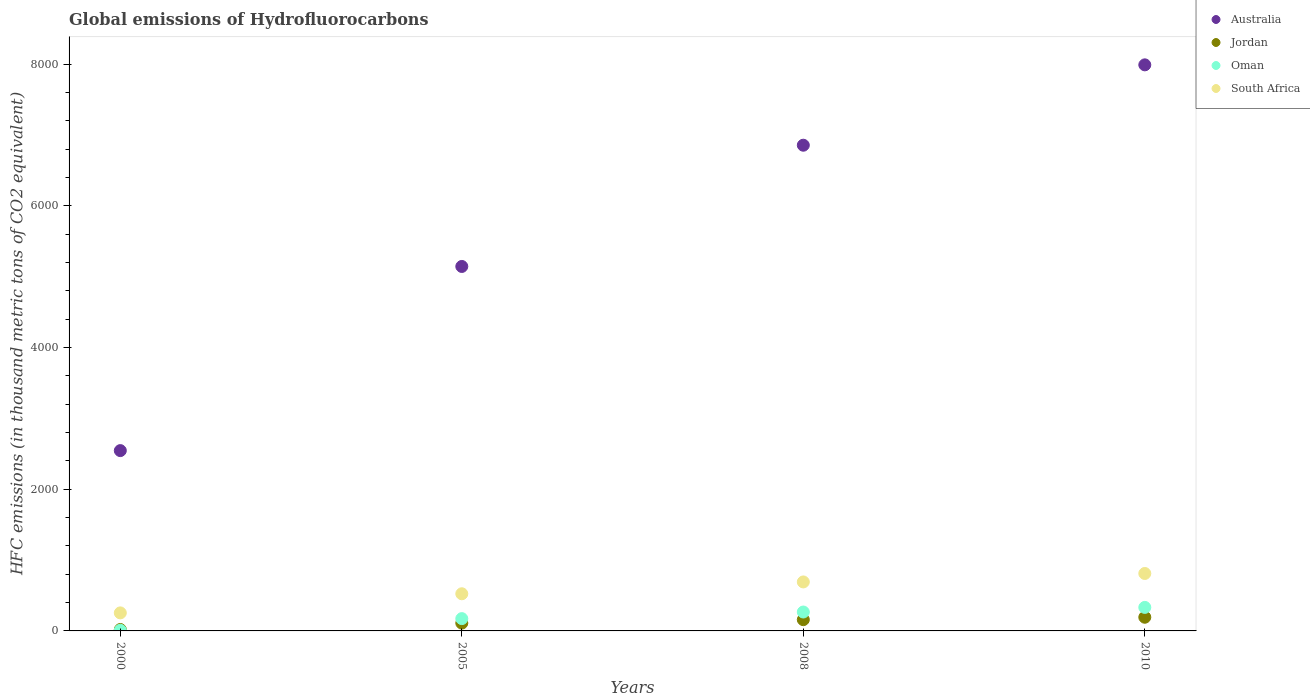How many different coloured dotlines are there?
Offer a very short reply. 4. Is the number of dotlines equal to the number of legend labels?
Provide a short and direct response. Yes. What is the global emissions of Hydrofluorocarbons in South Africa in 2000?
Make the answer very short. 254.6. Across all years, what is the maximum global emissions of Hydrofluorocarbons in Jordan?
Make the answer very short. 193. Across all years, what is the minimum global emissions of Hydrofluorocarbons in Australia?
Your response must be concise. 2545.7. In which year was the global emissions of Hydrofluorocarbons in Jordan maximum?
Keep it short and to the point. 2010. What is the total global emissions of Hydrofluorocarbons in Oman in the graph?
Provide a short and direct response. 781.1. What is the difference between the global emissions of Hydrofluorocarbons in Jordan in 2005 and that in 2010?
Give a very brief answer. -82.7. What is the difference between the global emissions of Hydrofluorocarbons in Jordan in 2005 and the global emissions of Hydrofluorocarbons in South Africa in 2010?
Your answer should be compact. -700.7. What is the average global emissions of Hydrofluorocarbons in Australia per year?
Keep it short and to the point. 5635.18. In the year 2008, what is the difference between the global emissions of Hydrofluorocarbons in Jordan and global emissions of Hydrofluorocarbons in South Africa?
Make the answer very short. -532.8. In how many years, is the global emissions of Hydrofluorocarbons in Oman greater than 3600 thousand metric tons?
Your answer should be very brief. 0. What is the ratio of the global emissions of Hydrofluorocarbons in Jordan in 2000 to that in 2008?
Make the answer very short. 0.12. Is the global emissions of Hydrofluorocarbons in Australia in 2000 less than that in 2005?
Your response must be concise. Yes. Is the difference between the global emissions of Hydrofluorocarbons in Jordan in 2000 and 2008 greater than the difference between the global emissions of Hydrofluorocarbons in South Africa in 2000 and 2008?
Ensure brevity in your answer.  Yes. What is the difference between the highest and the second highest global emissions of Hydrofluorocarbons in Jordan?
Provide a short and direct response. 34.2. What is the difference between the highest and the lowest global emissions of Hydrofluorocarbons in Australia?
Your answer should be very brief. 5446.3. In how many years, is the global emissions of Hydrofluorocarbons in Oman greater than the average global emissions of Hydrofluorocarbons in Oman taken over all years?
Ensure brevity in your answer.  2. Is the sum of the global emissions of Hydrofluorocarbons in Oman in 2005 and 2008 greater than the maximum global emissions of Hydrofluorocarbons in South Africa across all years?
Provide a short and direct response. No. Is it the case that in every year, the sum of the global emissions of Hydrofluorocarbons in Jordan and global emissions of Hydrofluorocarbons in South Africa  is greater than the sum of global emissions of Hydrofluorocarbons in Australia and global emissions of Hydrofluorocarbons in Oman?
Offer a very short reply. No. Is it the case that in every year, the sum of the global emissions of Hydrofluorocarbons in Jordan and global emissions of Hydrofluorocarbons in Oman  is greater than the global emissions of Hydrofluorocarbons in Australia?
Your answer should be very brief. No. Does the global emissions of Hydrofluorocarbons in Australia monotonically increase over the years?
Your answer should be very brief. Yes. Is the global emissions of Hydrofluorocarbons in Australia strictly greater than the global emissions of Hydrofluorocarbons in Jordan over the years?
Provide a short and direct response. Yes. Is the global emissions of Hydrofluorocarbons in Jordan strictly less than the global emissions of Hydrofluorocarbons in Australia over the years?
Your response must be concise. Yes. How many years are there in the graph?
Your answer should be compact. 4. Are the values on the major ticks of Y-axis written in scientific E-notation?
Make the answer very short. No. Does the graph contain any zero values?
Offer a very short reply. No. Where does the legend appear in the graph?
Provide a short and direct response. Top right. How are the legend labels stacked?
Ensure brevity in your answer.  Vertical. What is the title of the graph?
Make the answer very short. Global emissions of Hydrofluorocarbons. What is the label or title of the X-axis?
Provide a short and direct response. Years. What is the label or title of the Y-axis?
Give a very brief answer. HFC emissions (in thousand metric tons of CO2 equivalent). What is the HFC emissions (in thousand metric tons of CO2 equivalent) of Australia in 2000?
Offer a very short reply. 2545.7. What is the HFC emissions (in thousand metric tons of CO2 equivalent) in Jordan in 2000?
Provide a short and direct response. 19.7. What is the HFC emissions (in thousand metric tons of CO2 equivalent) of South Africa in 2000?
Offer a terse response. 254.6. What is the HFC emissions (in thousand metric tons of CO2 equivalent) of Australia in 2005?
Provide a short and direct response. 5145.6. What is the HFC emissions (in thousand metric tons of CO2 equivalent) in Jordan in 2005?
Keep it short and to the point. 110.3. What is the HFC emissions (in thousand metric tons of CO2 equivalent) of Oman in 2005?
Give a very brief answer. 173.6. What is the HFC emissions (in thousand metric tons of CO2 equivalent) in South Africa in 2005?
Ensure brevity in your answer.  524.5. What is the HFC emissions (in thousand metric tons of CO2 equivalent) of Australia in 2008?
Provide a short and direct response. 6857.4. What is the HFC emissions (in thousand metric tons of CO2 equivalent) of Jordan in 2008?
Provide a succinct answer. 158.8. What is the HFC emissions (in thousand metric tons of CO2 equivalent) in Oman in 2008?
Make the answer very short. 266.9. What is the HFC emissions (in thousand metric tons of CO2 equivalent) of South Africa in 2008?
Your response must be concise. 691.6. What is the HFC emissions (in thousand metric tons of CO2 equivalent) of Australia in 2010?
Your answer should be very brief. 7992. What is the HFC emissions (in thousand metric tons of CO2 equivalent) in Jordan in 2010?
Your answer should be compact. 193. What is the HFC emissions (in thousand metric tons of CO2 equivalent) of Oman in 2010?
Your answer should be very brief. 332. What is the HFC emissions (in thousand metric tons of CO2 equivalent) in South Africa in 2010?
Your response must be concise. 811. Across all years, what is the maximum HFC emissions (in thousand metric tons of CO2 equivalent) of Australia?
Your answer should be compact. 7992. Across all years, what is the maximum HFC emissions (in thousand metric tons of CO2 equivalent) in Jordan?
Keep it short and to the point. 193. Across all years, what is the maximum HFC emissions (in thousand metric tons of CO2 equivalent) in Oman?
Your answer should be very brief. 332. Across all years, what is the maximum HFC emissions (in thousand metric tons of CO2 equivalent) in South Africa?
Provide a succinct answer. 811. Across all years, what is the minimum HFC emissions (in thousand metric tons of CO2 equivalent) in Australia?
Give a very brief answer. 2545.7. Across all years, what is the minimum HFC emissions (in thousand metric tons of CO2 equivalent) of Oman?
Make the answer very short. 8.6. Across all years, what is the minimum HFC emissions (in thousand metric tons of CO2 equivalent) of South Africa?
Your answer should be compact. 254.6. What is the total HFC emissions (in thousand metric tons of CO2 equivalent) in Australia in the graph?
Keep it short and to the point. 2.25e+04. What is the total HFC emissions (in thousand metric tons of CO2 equivalent) in Jordan in the graph?
Your response must be concise. 481.8. What is the total HFC emissions (in thousand metric tons of CO2 equivalent) in Oman in the graph?
Your response must be concise. 781.1. What is the total HFC emissions (in thousand metric tons of CO2 equivalent) in South Africa in the graph?
Your answer should be compact. 2281.7. What is the difference between the HFC emissions (in thousand metric tons of CO2 equivalent) in Australia in 2000 and that in 2005?
Give a very brief answer. -2599.9. What is the difference between the HFC emissions (in thousand metric tons of CO2 equivalent) of Jordan in 2000 and that in 2005?
Provide a succinct answer. -90.6. What is the difference between the HFC emissions (in thousand metric tons of CO2 equivalent) in Oman in 2000 and that in 2005?
Your answer should be compact. -165. What is the difference between the HFC emissions (in thousand metric tons of CO2 equivalent) of South Africa in 2000 and that in 2005?
Provide a short and direct response. -269.9. What is the difference between the HFC emissions (in thousand metric tons of CO2 equivalent) of Australia in 2000 and that in 2008?
Your response must be concise. -4311.7. What is the difference between the HFC emissions (in thousand metric tons of CO2 equivalent) of Jordan in 2000 and that in 2008?
Provide a short and direct response. -139.1. What is the difference between the HFC emissions (in thousand metric tons of CO2 equivalent) of Oman in 2000 and that in 2008?
Your answer should be compact. -258.3. What is the difference between the HFC emissions (in thousand metric tons of CO2 equivalent) of South Africa in 2000 and that in 2008?
Your answer should be compact. -437. What is the difference between the HFC emissions (in thousand metric tons of CO2 equivalent) in Australia in 2000 and that in 2010?
Your answer should be compact. -5446.3. What is the difference between the HFC emissions (in thousand metric tons of CO2 equivalent) of Jordan in 2000 and that in 2010?
Make the answer very short. -173.3. What is the difference between the HFC emissions (in thousand metric tons of CO2 equivalent) of Oman in 2000 and that in 2010?
Keep it short and to the point. -323.4. What is the difference between the HFC emissions (in thousand metric tons of CO2 equivalent) of South Africa in 2000 and that in 2010?
Provide a succinct answer. -556.4. What is the difference between the HFC emissions (in thousand metric tons of CO2 equivalent) of Australia in 2005 and that in 2008?
Keep it short and to the point. -1711.8. What is the difference between the HFC emissions (in thousand metric tons of CO2 equivalent) in Jordan in 2005 and that in 2008?
Make the answer very short. -48.5. What is the difference between the HFC emissions (in thousand metric tons of CO2 equivalent) in Oman in 2005 and that in 2008?
Offer a very short reply. -93.3. What is the difference between the HFC emissions (in thousand metric tons of CO2 equivalent) of South Africa in 2005 and that in 2008?
Offer a terse response. -167.1. What is the difference between the HFC emissions (in thousand metric tons of CO2 equivalent) in Australia in 2005 and that in 2010?
Offer a very short reply. -2846.4. What is the difference between the HFC emissions (in thousand metric tons of CO2 equivalent) of Jordan in 2005 and that in 2010?
Keep it short and to the point. -82.7. What is the difference between the HFC emissions (in thousand metric tons of CO2 equivalent) in Oman in 2005 and that in 2010?
Offer a very short reply. -158.4. What is the difference between the HFC emissions (in thousand metric tons of CO2 equivalent) in South Africa in 2005 and that in 2010?
Offer a very short reply. -286.5. What is the difference between the HFC emissions (in thousand metric tons of CO2 equivalent) in Australia in 2008 and that in 2010?
Keep it short and to the point. -1134.6. What is the difference between the HFC emissions (in thousand metric tons of CO2 equivalent) in Jordan in 2008 and that in 2010?
Your answer should be compact. -34.2. What is the difference between the HFC emissions (in thousand metric tons of CO2 equivalent) of Oman in 2008 and that in 2010?
Your answer should be compact. -65.1. What is the difference between the HFC emissions (in thousand metric tons of CO2 equivalent) in South Africa in 2008 and that in 2010?
Ensure brevity in your answer.  -119.4. What is the difference between the HFC emissions (in thousand metric tons of CO2 equivalent) of Australia in 2000 and the HFC emissions (in thousand metric tons of CO2 equivalent) of Jordan in 2005?
Make the answer very short. 2435.4. What is the difference between the HFC emissions (in thousand metric tons of CO2 equivalent) in Australia in 2000 and the HFC emissions (in thousand metric tons of CO2 equivalent) in Oman in 2005?
Provide a short and direct response. 2372.1. What is the difference between the HFC emissions (in thousand metric tons of CO2 equivalent) in Australia in 2000 and the HFC emissions (in thousand metric tons of CO2 equivalent) in South Africa in 2005?
Make the answer very short. 2021.2. What is the difference between the HFC emissions (in thousand metric tons of CO2 equivalent) in Jordan in 2000 and the HFC emissions (in thousand metric tons of CO2 equivalent) in Oman in 2005?
Your response must be concise. -153.9. What is the difference between the HFC emissions (in thousand metric tons of CO2 equivalent) of Jordan in 2000 and the HFC emissions (in thousand metric tons of CO2 equivalent) of South Africa in 2005?
Make the answer very short. -504.8. What is the difference between the HFC emissions (in thousand metric tons of CO2 equivalent) in Oman in 2000 and the HFC emissions (in thousand metric tons of CO2 equivalent) in South Africa in 2005?
Your answer should be very brief. -515.9. What is the difference between the HFC emissions (in thousand metric tons of CO2 equivalent) in Australia in 2000 and the HFC emissions (in thousand metric tons of CO2 equivalent) in Jordan in 2008?
Make the answer very short. 2386.9. What is the difference between the HFC emissions (in thousand metric tons of CO2 equivalent) of Australia in 2000 and the HFC emissions (in thousand metric tons of CO2 equivalent) of Oman in 2008?
Your answer should be very brief. 2278.8. What is the difference between the HFC emissions (in thousand metric tons of CO2 equivalent) in Australia in 2000 and the HFC emissions (in thousand metric tons of CO2 equivalent) in South Africa in 2008?
Provide a short and direct response. 1854.1. What is the difference between the HFC emissions (in thousand metric tons of CO2 equivalent) in Jordan in 2000 and the HFC emissions (in thousand metric tons of CO2 equivalent) in Oman in 2008?
Provide a short and direct response. -247.2. What is the difference between the HFC emissions (in thousand metric tons of CO2 equivalent) of Jordan in 2000 and the HFC emissions (in thousand metric tons of CO2 equivalent) of South Africa in 2008?
Provide a succinct answer. -671.9. What is the difference between the HFC emissions (in thousand metric tons of CO2 equivalent) of Oman in 2000 and the HFC emissions (in thousand metric tons of CO2 equivalent) of South Africa in 2008?
Provide a short and direct response. -683. What is the difference between the HFC emissions (in thousand metric tons of CO2 equivalent) of Australia in 2000 and the HFC emissions (in thousand metric tons of CO2 equivalent) of Jordan in 2010?
Your response must be concise. 2352.7. What is the difference between the HFC emissions (in thousand metric tons of CO2 equivalent) of Australia in 2000 and the HFC emissions (in thousand metric tons of CO2 equivalent) of Oman in 2010?
Your answer should be very brief. 2213.7. What is the difference between the HFC emissions (in thousand metric tons of CO2 equivalent) in Australia in 2000 and the HFC emissions (in thousand metric tons of CO2 equivalent) in South Africa in 2010?
Ensure brevity in your answer.  1734.7. What is the difference between the HFC emissions (in thousand metric tons of CO2 equivalent) in Jordan in 2000 and the HFC emissions (in thousand metric tons of CO2 equivalent) in Oman in 2010?
Your answer should be compact. -312.3. What is the difference between the HFC emissions (in thousand metric tons of CO2 equivalent) in Jordan in 2000 and the HFC emissions (in thousand metric tons of CO2 equivalent) in South Africa in 2010?
Keep it short and to the point. -791.3. What is the difference between the HFC emissions (in thousand metric tons of CO2 equivalent) of Oman in 2000 and the HFC emissions (in thousand metric tons of CO2 equivalent) of South Africa in 2010?
Offer a terse response. -802.4. What is the difference between the HFC emissions (in thousand metric tons of CO2 equivalent) of Australia in 2005 and the HFC emissions (in thousand metric tons of CO2 equivalent) of Jordan in 2008?
Your answer should be compact. 4986.8. What is the difference between the HFC emissions (in thousand metric tons of CO2 equivalent) in Australia in 2005 and the HFC emissions (in thousand metric tons of CO2 equivalent) in Oman in 2008?
Offer a very short reply. 4878.7. What is the difference between the HFC emissions (in thousand metric tons of CO2 equivalent) of Australia in 2005 and the HFC emissions (in thousand metric tons of CO2 equivalent) of South Africa in 2008?
Ensure brevity in your answer.  4454. What is the difference between the HFC emissions (in thousand metric tons of CO2 equivalent) in Jordan in 2005 and the HFC emissions (in thousand metric tons of CO2 equivalent) in Oman in 2008?
Provide a succinct answer. -156.6. What is the difference between the HFC emissions (in thousand metric tons of CO2 equivalent) in Jordan in 2005 and the HFC emissions (in thousand metric tons of CO2 equivalent) in South Africa in 2008?
Provide a succinct answer. -581.3. What is the difference between the HFC emissions (in thousand metric tons of CO2 equivalent) in Oman in 2005 and the HFC emissions (in thousand metric tons of CO2 equivalent) in South Africa in 2008?
Ensure brevity in your answer.  -518. What is the difference between the HFC emissions (in thousand metric tons of CO2 equivalent) in Australia in 2005 and the HFC emissions (in thousand metric tons of CO2 equivalent) in Jordan in 2010?
Provide a succinct answer. 4952.6. What is the difference between the HFC emissions (in thousand metric tons of CO2 equivalent) in Australia in 2005 and the HFC emissions (in thousand metric tons of CO2 equivalent) in Oman in 2010?
Provide a short and direct response. 4813.6. What is the difference between the HFC emissions (in thousand metric tons of CO2 equivalent) in Australia in 2005 and the HFC emissions (in thousand metric tons of CO2 equivalent) in South Africa in 2010?
Keep it short and to the point. 4334.6. What is the difference between the HFC emissions (in thousand metric tons of CO2 equivalent) in Jordan in 2005 and the HFC emissions (in thousand metric tons of CO2 equivalent) in Oman in 2010?
Make the answer very short. -221.7. What is the difference between the HFC emissions (in thousand metric tons of CO2 equivalent) of Jordan in 2005 and the HFC emissions (in thousand metric tons of CO2 equivalent) of South Africa in 2010?
Ensure brevity in your answer.  -700.7. What is the difference between the HFC emissions (in thousand metric tons of CO2 equivalent) in Oman in 2005 and the HFC emissions (in thousand metric tons of CO2 equivalent) in South Africa in 2010?
Your response must be concise. -637.4. What is the difference between the HFC emissions (in thousand metric tons of CO2 equivalent) in Australia in 2008 and the HFC emissions (in thousand metric tons of CO2 equivalent) in Jordan in 2010?
Keep it short and to the point. 6664.4. What is the difference between the HFC emissions (in thousand metric tons of CO2 equivalent) of Australia in 2008 and the HFC emissions (in thousand metric tons of CO2 equivalent) of Oman in 2010?
Make the answer very short. 6525.4. What is the difference between the HFC emissions (in thousand metric tons of CO2 equivalent) of Australia in 2008 and the HFC emissions (in thousand metric tons of CO2 equivalent) of South Africa in 2010?
Your answer should be compact. 6046.4. What is the difference between the HFC emissions (in thousand metric tons of CO2 equivalent) in Jordan in 2008 and the HFC emissions (in thousand metric tons of CO2 equivalent) in Oman in 2010?
Offer a terse response. -173.2. What is the difference between the HFC emissions (in thousand metric tons of CO2 equivalent) in Jordan in 2008 and the HFC emissions (in thousand metric tons of CO2 equivalent) in South Africa in 2010?
Your answer should be compact. -652.2. What is the difference between the HFC emissions (in thousand metric tons of CO2 equivalent) of Oman in 2008 and the HFC emissions (in thousand metric tons of CO2 equivalent) of South Africa in 2010?
Offer a very short reply. -544.1. What is the average HFC emissions (in thousand metric tons of CO2 equivalent) of Australia per year?
Your response must be concise. 5635.18. What is the average HFC emissions (in thousand metric tons of CO2 equivalent) of Jordan per year?
Offer a terse response. 120.45. What is the average HFC emissions (in thousand metric tons of CO2 equivalent) of Oman per year?
Give a very brief answer. 195.28. What is the average HFC emissions (in thousand metric tons of CO2 equivalent) in South Africa per year?
Keep it short and to the point. 570.42. In the year 2000, what is the difference between the HFC emissions (in thousand metric tons of CO2 equivalent) in Australia and HFC emissions (in thousand metric tons of CO2 equivalent) in Jordan?
Make the answer very short. 2526. In the year 2000, what is the difference between the HFC emissions (in thousand metric tons of CO2 equivalent) in Australia and HFC emissions (in thousand metric tons of CO2 equivalent) in Oman?
Your response must be concise. 2537.1. In the year 2000, what is the difference between the HFC emissions (in thousand metric tons of CO2 equivalent) in Australia and HFC emissions (in thousand metric tons of CO2 equivalent) in South Africa?
Your response must be concise. 2291.1. In the year 2000, what is the difference between the HFC emissions (in thousand metric tons of CO2 equivalent) of Jordan and HFC emissions (in thousand metric tons of CO2 equivalent) of Oman?
Offer a terse response. 11.1. In the year 2000, what is the difference between the HFC emissions (in thousand metric tons of CO2 equivalent) of Jordan and HFC emissions (in thousand metric tons of CO2 equivalent) of South Africa?
Your response must be concise. -234.9. In the year 2000, what is the difference between the HFC emissions (in thousand metric tons of CO2 equivalent) of Oman and HFC emissions (in thousand metric tons of CO2 equivalent) of South Africa?
Give a very brief answer. -246. In the year 2005, what is the difference between the HFC emissions (in thousand metric tons of CO2 equivalent) in Australia and HFC emissions (in thousand metric tons of CO2 equivalent) in Jordan?
Give a very brief answer. 5035.3. In the year 2005, what is the difference between the HFC emissions (in thousand metric tons of CO2 equivalent) of Australia and HFC emissions (in thousand metric tons of CO2 equivalent) of Oman?
Offer a terse response. 4972. In the year 2005, what is the difference between the HFC emissions (in thousand metric tons of CO2 equivalent) in Australia and HFC emissions (in thousand metric tons of CO2 equivalent) in South Africa?
Give a very brief answer. 4621.1. In the year 2005, what is the difference between the HFC emissions (in thousand metric tons of CO2 equivalent) in Jordan and HFC emissions (in thousand metric tons of CO2 equivalent) in Oman?
Keep it short and to the point. -63.3. In the year 2005, what is the difference between the HFC emissions (in thousand metric tons of CO2 equivalent) of Jordan and HFC emissions (in thousand metric tons of CO2 equivalent) of South Africa?
Offer a terse response. -414.2. In the year 2005, what is the difference between the HFC emissions (in thousand metric tons of CO2 equivalent) of Oman and HFC emissions (in thousand metric tons of CO2 equivalent) of South Africa?
Your answer should be very brief. -350.9. In the year 2008, what is the difference between the HFC emissions (in thousand metric tons of CO2 equivalent) in Australia and HFC emissions (in thousand metric tons of CO2 equivalent) in Jordan?
Keep it short and to the point. 6698.6. In the year 2008, what is the difference between the HFC emissions (in thousand metric tons of CO2 equivalent) of Australia and HFC emissions (in thousand metric tons of CO2 equivalent) of Oman?
Offer a very short reply. 6590.5. In the year 2008, what is the difference between the HFC emissions (in thousand metric tons of CO2 equivalent) of Australia and HFC emissions (in thousand metric tons of CO2 equivalent) of South Africa?
Keep it short and to the point. 6165.8. In the year 2008, what is the difference between the HFC emissions (in thousand metric tons of CO2 equivalent) in Jordan and HFC emissions (in thousand metric tons of CO2 equivalent) in Oman?
Your answer should be compact. -108.1. In the year 2008, what is the difference between the HFC emissions (in thousand metric tons of CO2 equivalent) of Jordan and HFC emissions (in thousand metric tons of CO2 equivalent) of South Africa?
Your response must be concise. -532.8. In the year 2008, what is the difference between the HFC emissions (in thousand metric tons of CO2 equivalent) of Oman and HFC emissions (in thousand metric tons of CO2 equivalent) of South Africa?
Ensure brevity in your answer.  -424.7. In the year 2010, what is the difference between the HFC emissions (in thousand metric tons of CO2 equivalent) in Australia and HFC emissions (in thousand metric tons of CO2 equivalent) in Jordan?
Provide a short and direct response. 7799. In the year 2010, what is the difference between the HFC emissions (in thousand metric tons of CO2 equivalent) in Australia and HFC emissions (in thousand metric tons of CO2 equivalent) in Oman?
Keep it short and to the point. 7660. In the year 2010, what is the difference between the HFC emissions (in thousand metric tons of CO2 equivalent) of Australia and HFC emissions (in thousand metric tons of CO2 equivalent) of South Africa?
Your answer should be compact. 7181. In the year 2010, what is the difference between the HFC emissions (in thousand metric tons of CO2 equivalent) in Jordan and HFC emissions (in thousand metric tons of CO2 equivalent) in Oman?
Your response must be concise. -139. In the year 2010, what is the difference between the HFC emissions (in thousand metric tons of CO2 equivalent) in Jordan and HFC emissions (in thousand metric tons of CO2 equivalent) in South Africa?
Your response must be concise. -618. In the year 2010, what is the difference between the HFC emissions (in thousand metric tons of CO2 equivalent) in Oman and HFC emissions (in thousand metric tons of CO2 equivalent) in South Africa?
Provide a short and direct response. -479. What is the ratio of the HFC emissions (in thousand metric tons of CO2 equivalent) in Australia in 2000 to that in 2005?
Make the answer very short. 0.49. What is the ratio of the HFC emissions (in thousand metric tons of CO2 equivalent) of Jordan in 2000 to that in 2005?
Keep it short and to the point. 0.18. What is the ratio of the HFC emissions (in thousand metric tons of CO2 equivalent) in Oman in 2000 to that in 2005?
Offer a terse response. 0.05. What is the ratio of the HFC emissions (in thousand metric tons of CO2 equivalent) of South Africa in 2000 to that in 2005?
Your response must be concise. 0.49. What is the ratio of the HFC emissions (in thousand metric tons of CO2 equivalent) of Australia in 2000 to that in 2008?
Offer a very short reply. 0.37. What is the ratio of the HFC emissions (in thousand metric tons of CO2 equivalent) of Jordan in 2000 to that in 2008?
Provide a succinct answer. 0.12. What is the ratio of the HFC emissions (in thousand metric tons of CO2 equivalent) in Oman in 2000 to that in 2008?
Your response must be concise. 0.03. What is the ratio of the HFC emissions (in thousand metric tons of CO2 equivalent) of South Africa in 2000 to that in 2008?
Your answer should be very brief. 0.37. What is the ratio of the HFC emissions (in thousand metric tons of CO2 equivalent) in Australia in 2000 to that in 2010?
Your answer should be very brief. 0.32. What is the ratio of the HFC emissions (in thousand metric tons of CO2 equivalent) of Jordan in 2000 to that in 2010?
Provide a short and direct response. 0.1. What is the ratio of the HFC emissions (in thousand metric tons of CO2 equivalent) in Oman in 2000 to that in 2010?
Make the answer very short. 0.03. What is the ratio of the HFC emissions (in thousand metric tons of CO2 equivalent) of South Africa in 2000 to that in 2010?
Give a very brief answer. 0.31. What is the ratio of the HFC emissions (in thousand metric tons of CO2 equivalent) of Australia in 2005 to that in 2008?
Offer a terse response. 0.75. What is the ratio of the HFC emissions (in thousand metric tons of CO2 equivalent) of Jordan in 2005 to that in 2008?
Your answer should be compact. 0.69. What is the ratio of the HFC emissions (in thousand metric tons of CO2 equivalent) in Oman in 2005 to that in 2008?
Offer a very short reply. 0.65. What is the ratio of the HFC emissions (in thousand metric tons of CO2 equivalent) of South Africa in 2005 to that in 2008?
Your response must be concise. 0.76. What is the ratio of the HFC emissions (in thousand metric tons of CO2 equivalent) in Australia in 2005 to that in 2010?
Keep it short and to the point. 0.64. What is the ratio of the HFC emissions (in thousand metric tons of CO2 equivalent) of Jordan in 2005 to that in 2010?
Your response must be concise. 0.57. What is the ratio of the HFC emissions (in thousand metric tons of CO2 equivalent) of Oman in 2005 to that in 2010?
Offer a very short reply. 0.52. What is the ratio of the HFC emissions (in thousand metric tons of CO2 equivalent) in South Africa in 2005 to that in 2010?
Provide a short and direct response. 0.65. What is the ratio of the HFC emissions (in thousand metric tons of CO2 equivalent) in Australia in 2008 to that in 2010?
Provide a short and direct response. 0.86. What is the ratio of the HFC emissions (in thousand metric tons of CO2 equivalent) in Jordan in 2008 to that in 2010?
Give a very brief answer. 0.82. What is the ratio of the HFC emissions (in thousand metric tons of CO2 equivalent) in Oman in 2008 to that in 2010?
Provide a short and direct response. 0.8. What is the ratio of the HFC emissions (in thousand metric tons of CO2 equivalent) in South Africa in 2008 to that in 2010?
Your answer should be compact. 0.85. What is the difference between the highest and the second highest HFC emissions (in thousand metric tons of CO2 equivalent) in Australia?
Your answer should be compact. 1134.6. What is the difference between the highest and the second highest HFC emissions (in thousand metric tons of CO2 equivalent) of Jordan?
Ensure brevity in your answer.  34.2. What is the difference between the highest and the second highest HFC emissions (in thousand metric tons of CO2 equivalent) in Oman?
Provide a short and direct response. 65.1. What is the difference between the highest and the second highest HFC emissions (in thousand metric tons of CO2 equivalent) in South Africa?
Offer a very short reply. 119.4. What is the difference between the highest and the lowest HFC emissions (in thousand metric tons of CO2 equivalent) of Australia?
Offer a very short reply. 5446.3. What is the difference between the highest and the lowest HFC emissions (in thousand metric tons of CO2 equivalent) of Jordan?
Give a very brief answer. 173.3. What is the difference between the highest and the lowest HFC emissions (in thousand metric tons of CO2 equivalent) of Oman?
Offer a terse response. 323.4. What is the difference between the highest and the lowest HFC emissions (in thousand metric tons of CO2 equivalent) of South Africa?
Your answer should be compact. 556.4. 